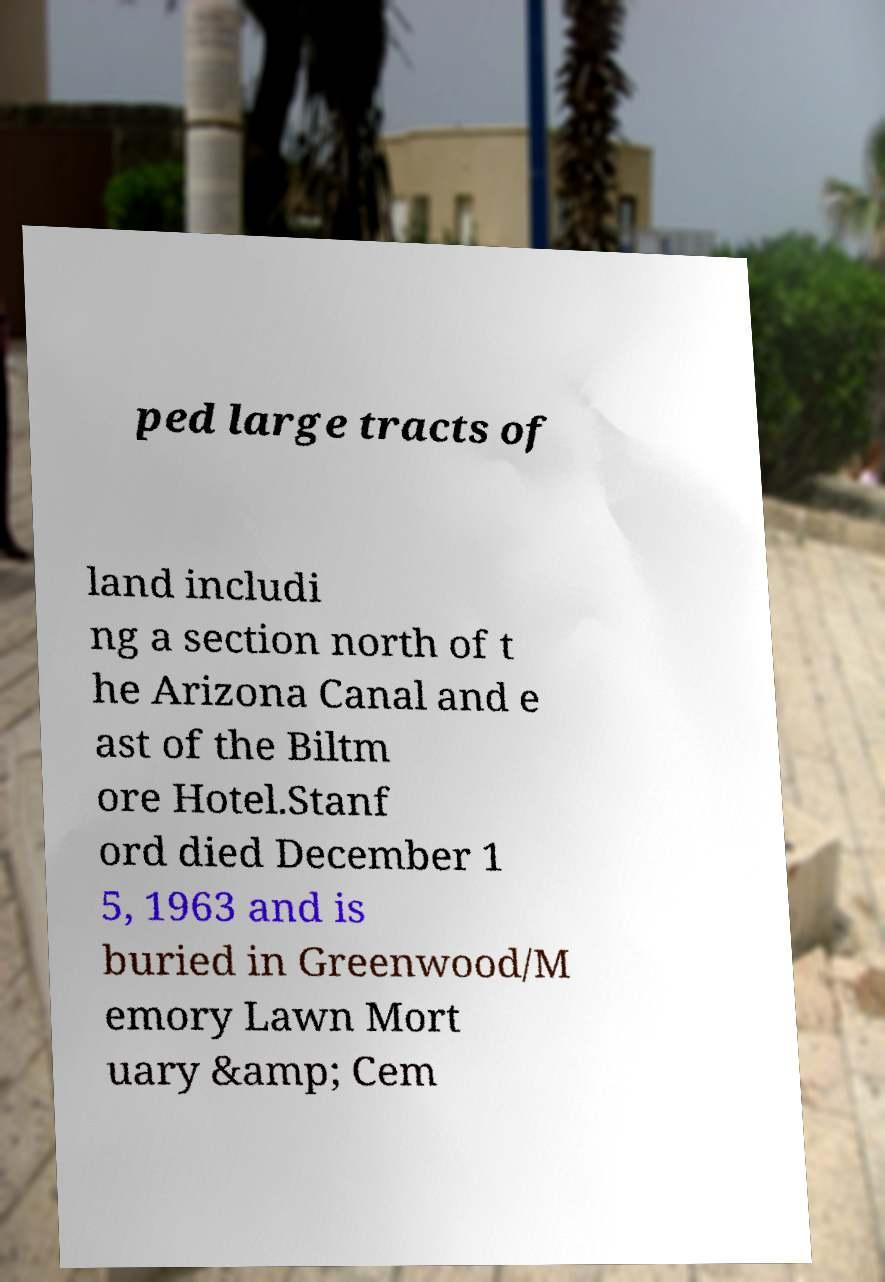Please read and relay the text visible in this image. What does it say? ped large tracts of land includi ng a section north of t he Arizona Canal and e ast of the Biltm ore Hotel.Stanf ord died December 1 5, 1963 and is buried in Greenwood/M emory Lawn Mort uary &amp; Cem 